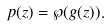<formula> <loc_0><loc_0><loc_500><loc_500>p ( z ) = \wp ( g ( z ) ) .</formula> 